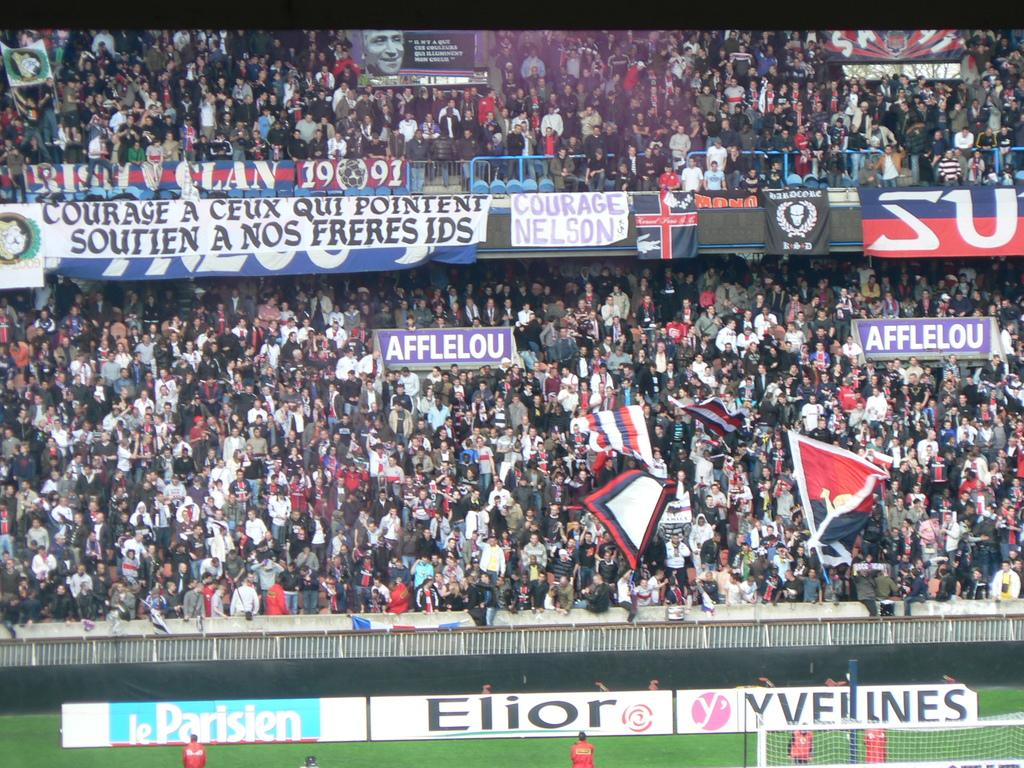<image>
Present a compact description of the photo's key features. a full sports stadium with ads for Elior on display 